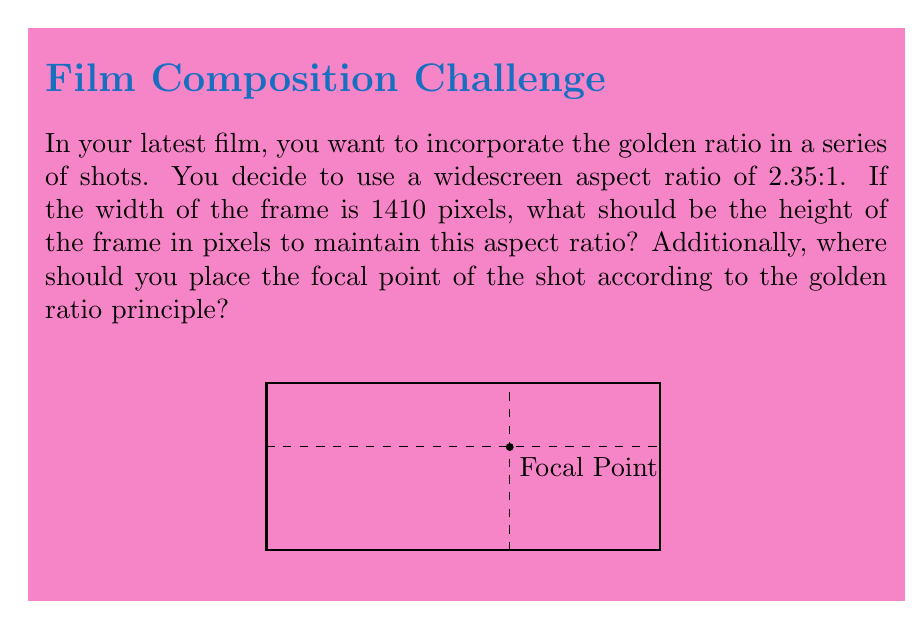Provide a solution to this math problem. 1. To find the height of the frame:
   - We know the aspect ratio is 2.35:1, which means width:height = 2.35:1
   - We can set up the equation: $\frac{1410}{height} = \frac{2.35}{1}$
   - Cross multiply: $1 \times 1410 = 2.35 \times height$
   - Solve for height: $height = \frac{1410}{2.35} = 600$ pixels

2. To find the focal point using the golden ratio:
   - The golden ratio is approximately 1.618:1 or 0.618:0.382 when normalized
   - For the width: $1410 \times 0.618 \approx 871$ pixels from the left
   - For the height: $600 \times 0.618 \approx 371$ pixels from the top

Therefore, the focal point should be placed at approximately (871, 371) pixels from the top-left corner of the frame.
Answer: Height: 600 pixels; Focal point: (871, 371) pixels from top-left 